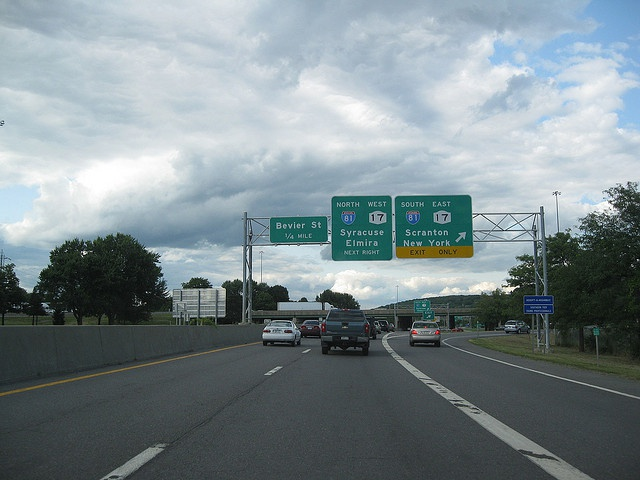Describe the objects in this image and their specific colors. I can see truck in darkgray, black, blue, purple, and darkblue tones, car in darkgray, black, and gray tones, car in darkgray, black, gray, and purple tones, car in darkgray, black, gray, darkblue, and blue tones, and car in darkgray, black, gray, purple, and darkblue tones in this image. 